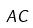Convert formula to latex. <formula><loc_0><loc_0><loc_500><loc_500>A C</formula> 